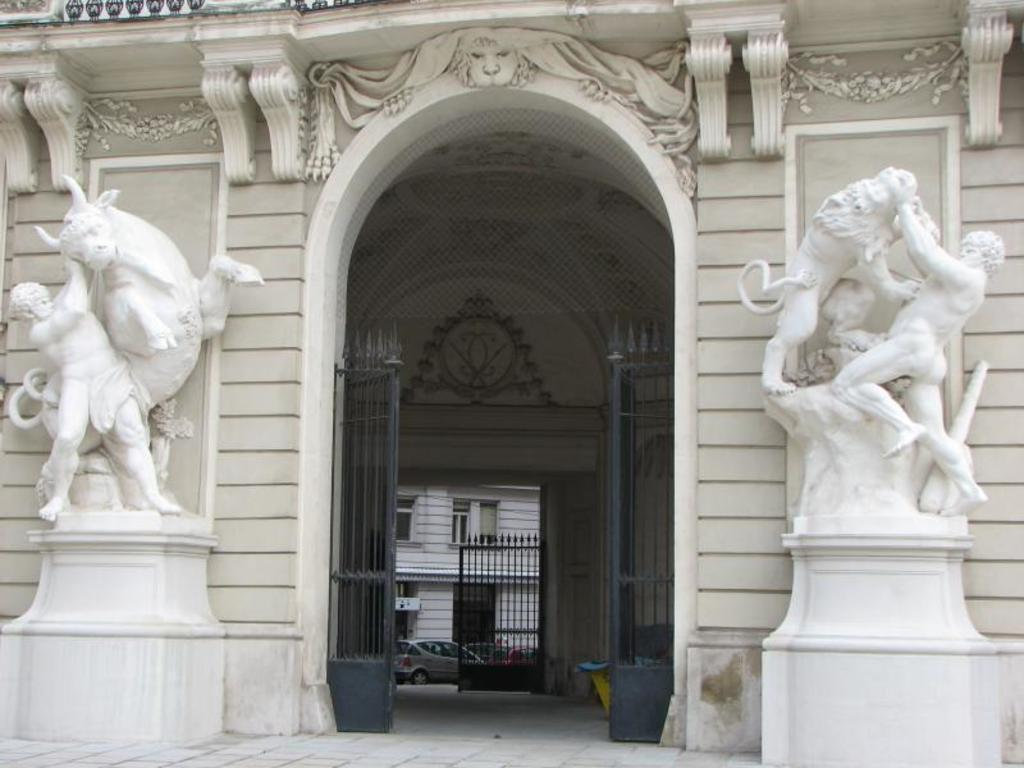What can be seen on both sides of the gate of the building in the image? There are white color statues on both sides of the gate of a building. What else can be seen in the background of the image? There is another gate and a white color building in the background. What is present on the road near the second gate? A vehicle is present on the road near the second gate. What type of apparatus is being used to burn the statues in the image? There is no apparatus or burning activity present in the image; the statues are white and stationary. 